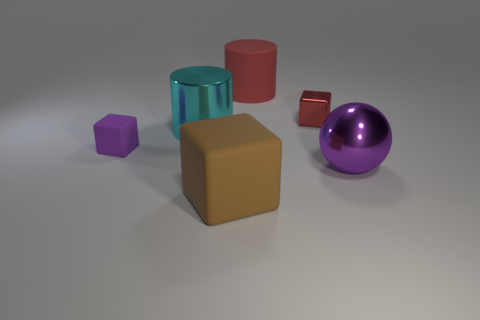How many objects are red metallic cubes or big things that are on the right side of the red matte thing?
Keep it short and to the point. 2. What number of tiny metallic blocks are behind the cube behind the tiny object that is to the left of the small metal thing?
Ensure brevity in your answer.  0. There is a purple object right of the cyan metallic cylinder; does it have the same shape as the red shiny thing?
Provide a succinct answer. No. There is a small cube that is on the right side of the large red rubber thing; is there a small red cube right of it?
Give a very brief answer. No. How many red blocks are there?
Offer a terse response. 1. What color is the large thing that is behind the purple shiny thing and in front of the big red matte object?
Keep it short and to the point. Cyan. What size is the brown rubber object that is the same shape as the tiny red object?
Make the answer very short. Large. How many brown objects have the same size as the cyan shiny cylinder?
Offer a very short reply. 1. What is the material of the brown cube?
Give a very brief answer. Rubber. There is a ball; are there any large cyan metal cylinders on the right side of it?
Offer a terse response. No. 